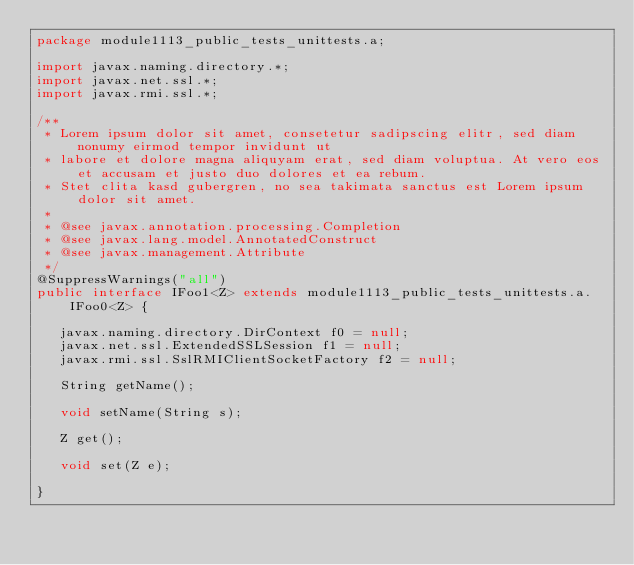Convert code to text. <code><loc_0><loc_0><loc_500><loc_500><_Java_>package module1113_public_tests_unittests.a;

import javax.naming.directory.*;
import javax.net.ssl.*;
import javax.rmi.ssl.*;

/**
 * Lorem ipsum dolor sit amet, consetetur sadipscing elitr, sed diam nonumy eirmod tempor invidunt ut 
 * labore et dolore magna aliquyam erat, sed diam voluptua. At vero eos et accusam et justo duo dolores et ea rebum. 
 * Stet clita kasd gubergren, no sea takimata sanctus est Lorem ipsum dolor sit amet. 
 *
 * @see javax.annotation.processing.Completion
 * @see javax.lang.model.AnnotatedConstruct
 * @see javax.management.Attribute
 */
@SuppressWarnings("all")
public interface IFoo1<Z> extends module1113_public_tests_unittests.a.IFoo0<Z> {

	 javax.naming.directory.DirContext f0 = null;
	 javax.net.ssl.ExtendedSSLSession f1 = null;
	 javax.rmi.ssl.SslRMIClientSocketFactory f2 = null;

	 String getName();

	 void setName(String s);

	 Z get();

	 void set(Z e);

}
</code> 